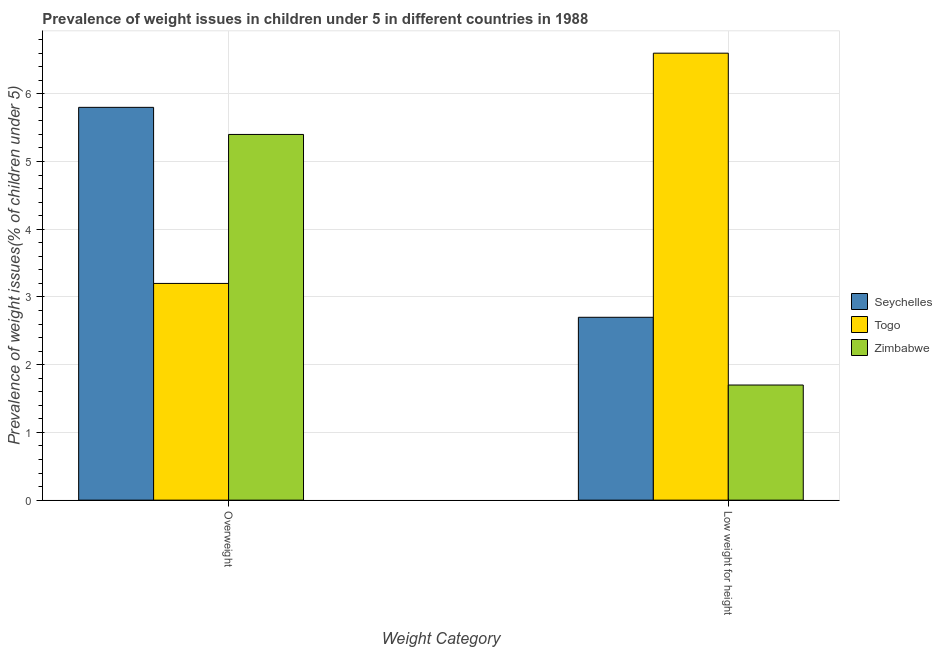How many different coloured bars are there?
Your response must be concise. 3. How many groups of bars are there?
Offer a very short reply. 2. Are the number of bars per tick equal to the number of legend labels?
Offer a very short reply. Yes. Are the number of bars on each tick of the X-axis equal?
Provide a short and direct response. Yes. How many bars are there on the 2nd tick from the right?
Your answer should be compact. 3. What is the label of the 2nd group of bars from the left?
Offer a terse response. Low weight for height. What is the percentage of underweight children in Seychelles?
Offer a very short reply. 2.7. Across all countries, what is the maximum percentage of underweight children?
Make the answer very short. 6.6. Across all countries, what is the minimum percentage of underweight children?
Offer a terse response. 1.7. In which country was the percentage of overweight children maximum?
Provide a short and direct response. Seychelles. In which country was the percentage of underweight children minimum?
Give a very brief answer. Zimbabwe. What is the total percentage of underweight children in the graph?
Provide a short and direct response. 11. What is the difference between the percentage of overweight children in Seychelles and that in Togo?
Make the answer very short. 2.6. What is the difference between the percentage of overweight children in Seychelles and the percentage of underweight children in Togo?
Give a very brief answer. -0.8. What is the average percentage of underweight children per country?
Provide a short and direct response. 3.67. What is the difference between the percentage of underweight children and percentage of overweight children in Seychelles?
Offer a terse response. -3.1. In how many countries, is the percentage of overweight children greater than 4 %?
Provide a short and direct response. 2. What is the ratio of the percentage of underweight children in Zimbabwe to that in Seychelles?
Keep it short and to the point. 0.63. Is the percentage of underweight children in Zimbabwe less than that in Togo?
Ensure brevity in your answer.  Yes. In how many countries, is the percentage of underweight children greater than the average percentage of underweight children taken over all countries?
Your answer should be very brief. 1. What does the 3rd bar from the left in Overweight represents?
Your answer should be very brief. Zimbabwe. What does the 1st bar from the right in Overweight represents?
Your answer should be very brief. Zimbabwe. Are all the bars in the graph horizontal?
Give a very brief answer. No. What is the difference between two consecutive major ticks on the Y-axis?
Offer a very short reply. 1. Are the values on the major ticks of Y-axis written in scientific E-notation?
Make the answer very short. No. Where does the legend appear in the graph?
Offer a terse response. Center right. How are the legend labels stacked?
Make the answer very short. Vertical. What is the title of the graph?
Provide a succinct answer. Prevalence of weight issues in children under 5 in different countries in 1988. Does "OECD members" appear as one of the legend labels in the graph?
Your answer should be compact. No. What is the label or title of the X-axis?
Offer a very short reply. Weight Category. What is the label or title of the Y-axis?
Ensure brevity in your answer.  Prevalence of weight issues(% of children under 5). What is the Prevalence of weight issues(% of children under 5) of Seychelles in Overweight?
Keep it short and to the point. 5.8. What is the Prevalence of weight issues(% of children under 5) of Togo in Overweight?
Provide a succinct answer. 3.2. What is the Prevalence of weight issues(% of children under 5) in Zimbabwe in Overweight?
Keep it short and to the point. 5.4. What is the Prevalence of weight issues(% of children under 5) in Seychelles in Low weight for height?
Make the answer very short. 2.7. What is the Prevalence of weight issues(% of children under 5) in Togo in Low weight for height?
Your answer should be compact. 6.6. What is the Prevalence of weight issues(% of children under 5) of Zimbabwe in Low weight for height?
Ensure brevity in your answer.  1.7. Across all Weight Category, what is the maximum Prevalence of weight issues(% of children under 5) in Seychelles?
Ensure brevity in your answer.  5.8. Across all Weight Category, what is the maximum Prevalence of weight issues(% of children under 5) of Togo?
Ensure brevity in your answer.  6.6. Across all Weight Category, what is the maximum Prevalence of weight issues(% of children under 5) of Zimbabwe?
Keep it short and to the point. 5.4. Across all Weight Category, what is the minimum Prevalence of weight issues(% of children under 5) in Seychelles?
Give a very brief answer. 2.7. Across all Weight Category, what is the minimum Prevalence of weight issues(% of children under 5) of Togo?
Make the answer very short. 3.2. Across all Weight Category, what is the minimum Prevalence of weight issues(% of children under 5) of Zimbabwe?
Keep it short and to the point. 1.7. What is the total Prevalence of weight issues(% of children under 5) in Seychelles in the graph?
Your answer should be compact. 8.5. What is the difference between the Prevalence of weight issues(% of children under 5) in Seychelles in Overweight and that in Low weight for height?
Give a very brief answer. 3.1. What is the difference between the Prevalence of weight issues(% of children under 5) of Togo in Overweight and that in Low weight for height?
Ensure brevity in your answer.  -3.4. What is the difference between the Prevalence of weight issues(% of children under 5) of Seychelles in Overweight and the Prevalence of weight issues(% of children under 5) of Togo in Low weight for height?
Your response must be concise. -0.8. What is the difference between the Prevalence of weight issues(% of children under 5) of Seychelles in Overweight and the Prevalence of weight issues(% of children under 5) of Zimbabwe in Low weight for height?
Give a very brief answer. 4.1. What is the average Prevalence of weight issues(% of children under 5) in Seychelles per Weight Category?
Your answer should be compact. 4.25. What is the average Prevalence of weight issues(% of children under 5) of Togo per Weight Category?
Provide a short and direct response. 4.9. What is the average Prevalence of weight issues(% of children under 5) in Zimbabwe per Weight Category?
Make the answer very short. 3.55. What is the difference between the Prevalence of weight issues(% of children under 5) in Seychelles and Prevalence of weight issues(% of children under 5) in Zimbabwe in Overweight?
Your answer should be compact. 0.4. What is the difference between the Prevalence of weight issues(% of children under 5) in Seychelles and Prevalence of weight issues(% of children under 5) in Zimbabwe in Low weight for height?
Your response must be concise. 1. What is the difference between the Prevalence of weight issues(% of children under 5) of Togo and Prevalence of weight issues(% of children under 5) of Zimbabwe in Low weight for height?
Your response must be concise. 4.9. What is the ratio of the Prevalence of weight issues(% of children under 5) of Seychelles in Overweight to that in Low weight for height?
Make the answer very short. 2.15. What is the ratio of the Prevalence of weight issues(% of children under 5) of Togo in Overweight to that in Low weight for height?
Ensure brevity in your answer.  0.48. What is the ratio of the Prevalence of weight issues(% of children under 5) in Zimbabwe in Overweight to that in Low weight for height?
Provide a short and direct response. 3.18. What is the difference between the highest and the second highest Prevalence of weight issues(% of children under 5) in Seychelles?
Your answer should be compact. 3.1. What is the difference between the highest and the second highest Prevalence of weight issues(% of children under 5) of Zimbabwe?
Give a very brief answer. 3.7. What is the difference between the highest and the lowest Prevalence of weight issues(% of children under 5) in Seychelles?
Offer a very short reply. 3.1. What is the difference between the highest and the lowest Prevalence of weight issues(% of children under 5) in Togo?
Give a very brief answer. 3.4. What is the difference between the highest and the lowest Prevalence of weight issues(% of children under 5) of Zimbabwe?
Offer a very short reply. 3.7. 